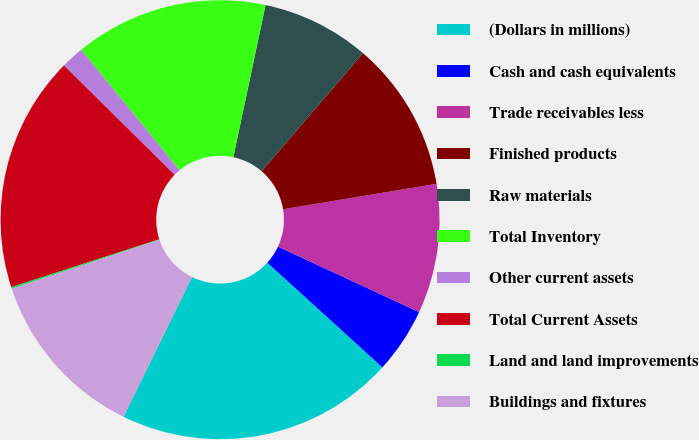<chart> <loc_0><loc_0><loc_500><loc_500><pie_chart><fcel>(Dollars in millions)<fcel>Cash and cash equivalents<fcel>Trade receivables less<fcel>Finished products<fcel>Raw materials<fcel>Total Inventory<fcel>Other current assets<fcel>Total Current Assets<fcel>Land and land improvements<fcel>Buildings and fixtures<nl><fcel>20.5%<fcel>4.83%<fcel>9.53%<fcel>11.1%<fcel>7.96%<fcel>14.23%<fcel>1.69%<fcel>17.37%<fcel>0.12%<fcel>12.66%<nl></chart> 